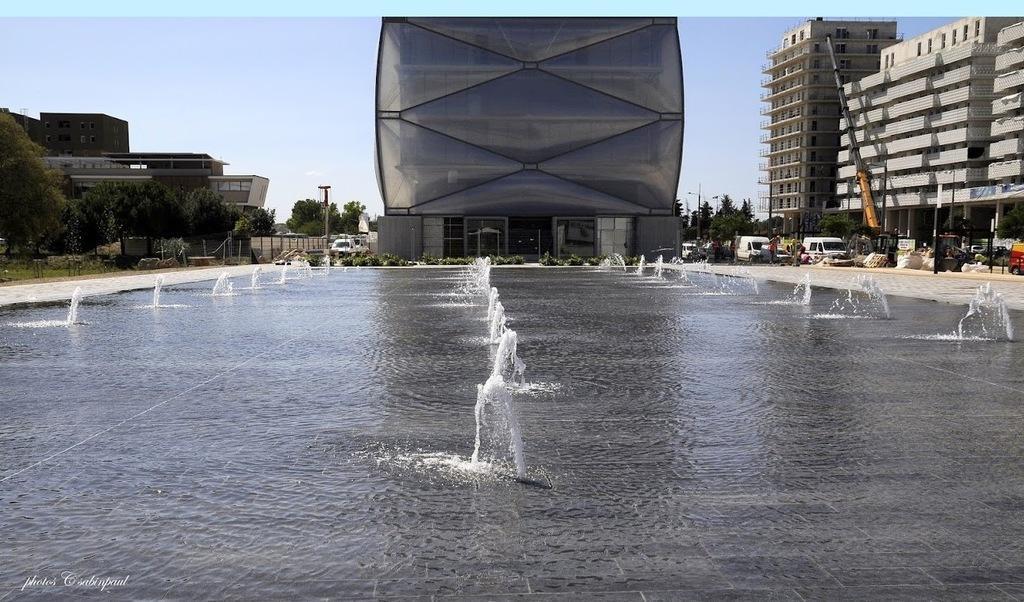In one or two sentences, can you explain what this image depicts? In this image we can see the fountains and the water. On the backside we can see some buildings, a crane, some vehicles on the ground, a group of trees, grass and the sky which looks cloudy. 